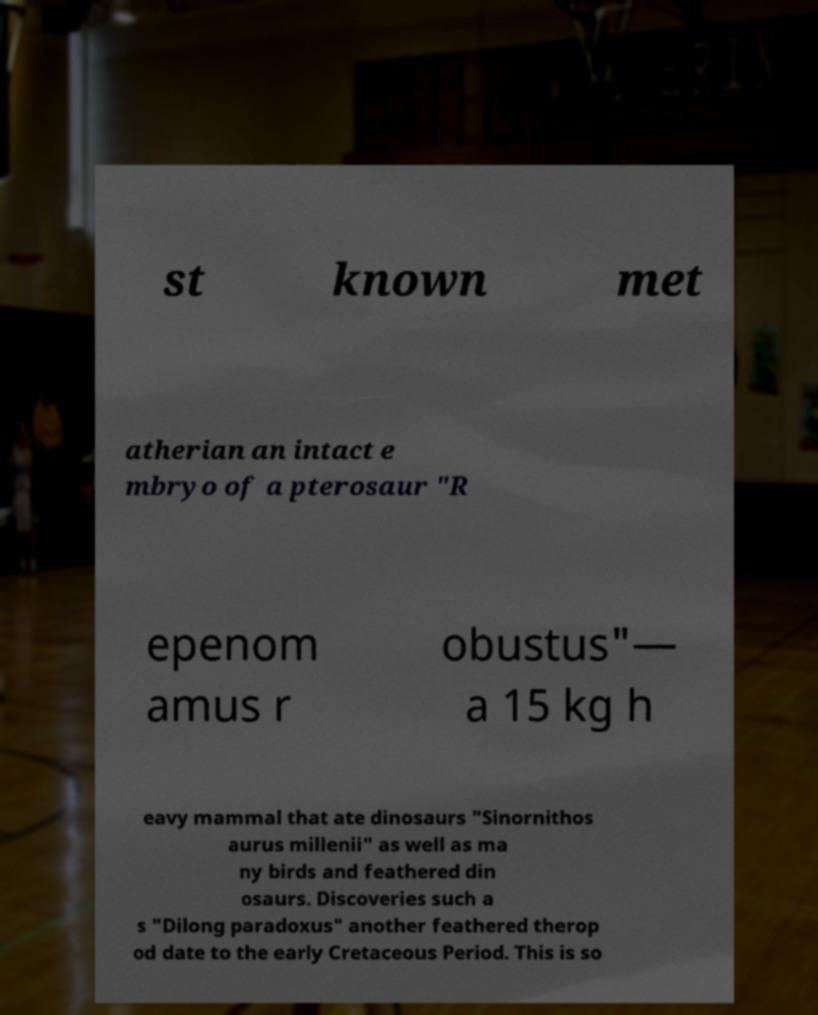There's text embedded in this image that I need extracted. Can you transcribe it verbatim? st known met atherian an intact e mbryo of a pterosaur "R epenom amus r obustus"— a 15 kg h eavy mammal that ate dinosaurs "Sinornithos aurus millenii" as well as ma ny birds and feathered din osaurs. Discoveries such a s "Dilong paradoxus" another feathered therop od date to the early Cretaceous Period. This is so 